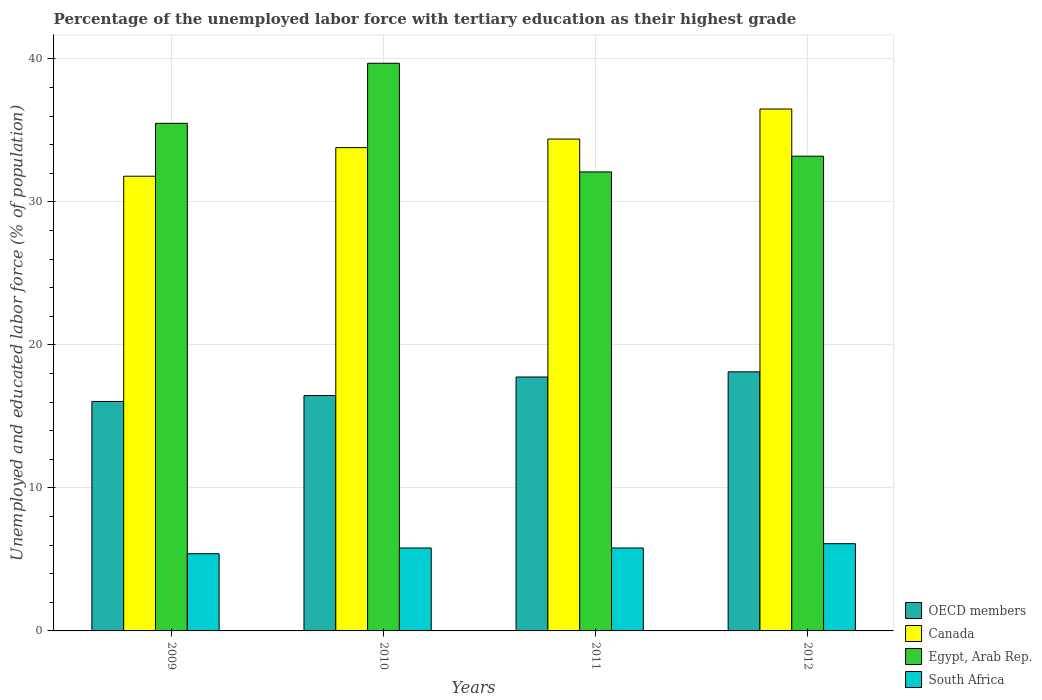How many different coloured bars are there?
Keep it short and to the point. 4. How many groups of bars are there?
Provide a succinct answer. 4. What is the percentage of the unemployed labor force with tertiary education in Canada in 2010?
Offer a very short reply. 33.8. Across all years, what is the maximum percentage of the unemployed labor force with tertiary education in OECD members?
Ensure brevity in your answer.  18.12. Across all years, what is the minimum percentage of the unemployed labor force with tertiary education in South Africa?
Your answer should be compact. 5.4. In which year was the percentage of the unemployed labor force with tertiary education in Egypt, Arab Rep. maximum?
Your answer should be compact. 2010. What is the total percentage of the unemployed labor force with tertiary education in Egypt, Arab Rep. in the graph?
Your answer should be very brief. 140.5. What is the difference between the percentage of the unemployed labor force with tertiary education in OECD members in 2009 and that in 2010?
Keep it short and to the point. -0.41. What is the difference between the percentage of the unemployed labor force with tertiary education in Egypt, Arab Rep. in 2011 and the percentage of the unemployed labor force with tertiary education in OECD members in 2010?
Offer a very short reply. 15.64. What is the average percentage of the unemployed labor force with tertiary education in South Africa per year?
Give a very brief answer. 5.78. In the year 2009, what is the difference between the percentage of the unemployed labor force with tertiary education in Canada and percentage of the unemployed labor force with tertiary education in Egypt, Arab Rep.?
Your answer should be compact. -3.7. In how many years, is the percentage of the unemployed labor force with tertiary education in South Africa greater than 2 %?
Ensure brevity in your answer.  4. What is the ratio of the percentage of the unemployed labor force with tertiary education in OECD members in 2010 to that in 2011?
Make the answer very short. 0.93. What is the difference between the highest and the second highest percentage of the unemployed labor force with tertiary education in Canada?
Give a very brief answer. 2.1. What is the difference between the highest and the lowest percentage of the unemployed labor force with tertiary education in South Africa?
Your response must be concise. 0.7. In how many years, is the percentage of the unemployed labor force with tertiary education in South Africa greater than the average percentage of the unemployed labor force with tertiary education in South Africa taken over all years?
Offer a very short reply. 3. Is the sum of the percentage of the unemployed labor force with tertiary education in OECD members in 2011 and 2012 greater than the maximum percentage of the unemployed labor force with tertiary education in Egypt, Arab Rep. across all years?
Your answer should be compact. No. Is it the case that in every year, the sum of the percentage of the unemployed labor force with tertiary education in Egypt, Arab Rep. and percentage of the unemployed labor force with tertiary education in South Africa is greater than the sum of percentage of the unemployed labor force with tertiary education in Canada and percentage of the unemployed labor force with tertiary education in OECD members?
Your response must be concise. No. What does the 2nd bar from the left in 2012 represents?
Your response must be concise. Canada. Are all the bars in the graph horizontal?
Ensure brevity in your answer.  No. Are the values on the major ticks of Y-axis written in scientific E-notation?
Offer a terse response. No. Does the graph contain any zero values?
Your answer should be compact. No. How are the legend labels stacked?
Keep it short and to the point. Vertical. What is the title of the graph?
Make the answer very short. Percentage of the unemployed labor force with tertiary education as their highest grade. What is the label or title of the X-axis?
Provide a short and direct response. Years. What is the label or title of the Y-axis?
Your response must be concise. Unemployed and educated labor force (% of population). What is the Unemployed and educated labor force (% of population) in OECD members in 2009?
Ensure brevity in your answer.  16.05. What is the Unemployed and educated labor force (% of population) in Canada in 2009?
Keep it short and to the point. 31.8. What is the Unemployed and educated labor force (% of population) in Egypt, Arab Rep. in 2009?
Your answer should be very brief. 35.5. What is the Unemployed and educated labor force (% of population) in South Africa in 2009?
Your answer should be compact. 5.4. What is the Unemployed and educated labor force (% of population) of OECD members in 2010?
Your answer should be compact. 16.46. What is the Unemployed and educated labor force (% of population) of Canada in 2010?
Offer a terse response. 33.8. What is the Unemployed and educated labor force (% of population) of Egypt, Arab Rep. in 2010?
Ensure brevity in your answer.  39.7. What is the Unemployed and educated labor force (% of population) in South Africa in 2010?
Your answer should be very brief. 5.8. What is the Unemployed and educated labor force (% of population) of OECD members in 2011?
Keep it short and to the point. 17.76. What is the Unemployed and educated labor force (% of population) in Canada in 2011?
Ensure brevity in your answer.  34.4. What is the Unemployed and educated labor force (% of population) in Egypt, Arab Rep. in 2011?
Ensure brevity in your answer.  32.1. What is the Unemployed and educated labor force (% of population) of South Africa in 2011?
Give a very brief answer. 5.8. What is the Unemployed and educated labor force (% of population) of OECD members in 2012?
Your answer should be compact. 18.12. What is the Unemployed and educated labor force (% of population) in Canada in 2012?
Your answer should be very brief. 36.5. What is the Unemployed and educated labor force (% of population) of Egypt, Arab Rep. in 2012?
Make the answer very short. 33.2. What is the Unemployed and educated labor force (% of population) in South Africa in 2012?
Your answer should be very brief. 6.1. Across all years, what is the maximum Unemployed and educated labor force (% of population) of OECD members?
Make the answer very short. 18.12. Across all years, what is the maximum Unemployed and educated labor force (% of population) in Canada?
Your answer should be very brief. 36.5. Across all years, what is the maximum Unemployed and educated labor force (% of population) in Egypt, Arab Rep.?
Provide a short and direct response. 39.7. Across all years, what is the maximum Unemployed and educated labor force (% of population) in South Africa?
Ensure brevity in your answer.  6.1. Across all years, what is the minimum Unemployed and educated labor force (% of population) of OECD members?
Your answer should be very brief. 16.05. Across all years, what is the minimum Unemployed and educated labor force (% of population) in Canada?
Give a very brief answer. 31.8. Across all years, what is the minimum Unemployed and educated labor force (% of population) in Egypt, Arab Rep.?
Your response must be concise. 32.1. Across all years, what is the minimum Unemployed and educated labor force (% of population) of South Africa?
Offer a very short reply. 5.4. What is the total Unemployed and educated labor force (% of population) in OECD members in the graph?
Keep it short and to the point. 68.39. What is the total Unemployed and educated labor force (% of population) of Canada in the graph?
Your response must be concise. 136.5. What is the total Unemployed and educated labor force (% of population) of Egypt, Arab Rep. in the graph?
Your answer should be very brief. 140.5. What is the total Unemployed and educated labor force (% of population) in South Africa in the graph?
Provide a short and direct response. 23.1. What is the difference between the Unemployed and educated labor force (% of population) of OECD members in 2009 and that in 2010?
Offer a very short reply. -0.41. What is the difference between the Unemployed and educated labor force (% of population) of Canada in 2009 and that in 2010?
Give a very brief answer. -2. What is the difference between the Unemployed and educated labor force (% of population) in OECD members in 2009 and that in 2011?
Give a very brief answer. -1.71. What is the difference between the Unemployed and educated labor force (% of population) in Canada in 2009 and that in 2011?
Your response must be concise. -2.6. What is the difference between the Unemployed and educated labor force (% of population) in South Africa in 2009 and that in 2011?
Provide a short and direct response. -0.4. What is the difference between the Unemployed and educated labor force (% of population) of OECD members in 2009 and that in 2012?
Make the answer very short. -2.07. What is the difference between the Unemployed and educated labor force (% of population) in Egypt, Arab Rep. in 2009 and that in 2012?
Offer a terse response. 2.3. What is the difference between the Unemployed and educated labor force (% of population) of OECD members in 2010 and that in 2011?
Make the answer very short. -1.3. What is the difference between the Unemployed and educated labor force (% of population) in Canada in 2010 and that in 2011?
Your answer should be compact. -0.6. What is the difference between the Unemployed and educated labor force (% of population) in South Africa in 2010 and that in 2011?
Your answer should be compact. 0. What is the difference between the Unemployed and educated labor force (% of population) of OECD members in 2010 and that in 2012?
Keep it short and to the point. -1.66. What is the difference between the Unemployed and educated labor force (% of population) of Egypt, Arab Rep. in 2010 and that in 2012?
Offer a terse response. 6.5. What is the difference between the Unemployed and educated labor force (% of population) of South Africa in 2010 and that in 2012?
Your response must be concise. -0.3. What is the difference between the Unemployed and educated labor force (% of population) in OECD members in 2011 and that in 2012?
Your answer should be very brief. -0.36. What is the difference between the Unemployed and educated labor force (% of population) of OECD members in 2009 and the Unemployed and educated labor force (% of population) of Canada in 2010?
Give a very brief answer. -17.75. What is the difference between the Unemployed and educated labor force (% of population) in OECD members in 2009 and the Unemployed and educated labor force (% of population) in Egypt, Arab Rep. in 2010?
Provide a short and direct response. -23.65. What is the difference between the Unemployed and educated labor force (% of population) in OECD members in 2009 and the Unemployed and educated labor force (% of population) in South Africa in 2010?
Keep it short and to the point. 10.25. What is the difference between the Unemployed and educated labor force (% of population) of Canada in 2009 and the Unemployed and educated labor force (% of population) of Egypt, Arab Rep. in 2010?
Provide a short and direct response. -7.9. What is the difference between the Unemployed and educated labor force (% of population) of Egypt, Arab Rep. in 2009 and the Unemployed and educated labor force (% of population) of South Africa in 2010?
Keep it short and to the point. 29.7. What is the difference between the Unemployed and educated labor force (% of population) of OECD members in 2009 and the Unemployed and educated labor force (% of population) of Canada in 2011?
Your response must be concise. -18.35. What is the difference between the Unemployed and educated labor force (% of population) of OECD members in 2009 and the Unemployed and educated labor force (% of population) of Egypt, Arab Rep. in 2011?
Your answer should be compact. -16.05. What is the difference between the Unemployed and educated labor force (% of population) in OECD members in 2009 and the Unemployed and educated labor force (% of population) in South Africa in 2011?
Give a very brief answer. 10.25. What is the difference between the Unemployed and educated labor force (% of population) of Egypt, Arab Rep. in 2009 and the Unemployed and educated labor force (% of population) of South Africa in 2011?
Give a very brief answer. 29.7. What is the difference between the Unemployed and educated labor force (% of population) of OECD members in 2009 and the Unemployed and educated labor force (% of population) of Canada in 2012?
Offer a very short reply. -20.45. What is the difference between the Unemployed and educated labor force (% of population) of OECD members in 2009 and the Unemployed and educated labor force (% of population) of Egypt, Arab Rep. in 2012?
Your answer should be very brief. -17.15. What is the difference between the Unemployed and educated labor force (% of population) in OECD members in 2009 and the Unemployed and educated labor force (% of population) in South Africa in 2012?
Make the answer very short. 9.95. What is the difference between the Unemployed and educated labor force (% of population) in Canada in 2009 and the Unemployed and educated labor force (% of population) in South Africa in 2012?
Offer a very short reply. 25.7. What is the difference between the Unemployed and educated labor force (% of population) in Egypt, Arab Rep. in 2009 and the Unemployed and educated labor force (% of population) in South Africa in 2012?
Provide a succinct answer. 29.4. What is the difference between the Unemployed and educated labor force (% of population) in OECD members in 2010 and the Unemployed and educated labor force (% of population) in Canada in 2011?
Offer a very short reply. -17.94. What is the difference between the Unemployed and educated labor force (% of population) of OECD members in 2010 and the Unemployed and educated labor force (% of population) of Egypt, Arab Rep. in 2011?
Provide a succinct answer. -15.64. What is the difference between the Unemployed and educated labor force (% of population) in OECD members in 2010 and the Unemployed and educated labor force (% of population) in South Africa in 2011?
Give a very brief answer. 10.66. What is the difference between the Unemployed and educated labor force (% of population) in Canada in 2010 and the Unemployed and educated labor force (% of population) in Egypt, Arab Rep. in 2011?
Your answer should be compact. 1.7. What is the difference between the Unemployed and educated labor force (% of population) of Egypt, Arab Rep. in 2010 and the Unemployed and educated labor force (% of population) of South Africa in 2011?
Offer a terse response. 33.9. What is the difference between the Unemployed and educated labor force (% of population) in OECD members in 2010 and the Unemployed and educated labor force (% of population) in Canada in 2012?
Ensure brevity in your answer.  -20.04. What is the difference between the Unemployed and educated labor force (% of population) in OECD members in 2010 and the Unemployed and educated labor force (% of population) in Egypt, Arab Rep. in 2012?
Give a very brief answer. -16.74. What is the difference between the Unemployed and educated labor force (% of population) in OECD members in 2010 and the Unemployed and educated labor force (% of population) in South Africa in 2012?
Ensure brevity in your answer.  10.36. What is the difference between the Unemployed and educated labor force (% of population) of Canada in 2010 and the Unemployed and educated labor force (% of population) of South Africa in 2012?
Ensure brevity in your answer.  27.7. What is the difference between the Unemployed and educated labor force (% of population) in Egypt, Arab Rep. in 2010 and the Unemployed and educated labor force (% of population) in South Africa in 2012?
Provide a short and direct response. 33.6. What is the difference between the Unemployed and educated labor force (% of population) in OECD members in 2011 and the Unemployed and educated labor force (% of population) in Canada in 2012?
Your answer should be compact. -18.74. What is the difference between the Unemployed and educated labor force (% of population) in OECD members in 2011 and the Unemployed and educated labor force (% of population) in Egypt, Arab Rep. in 2012?
Provide a short and direct response. -15.44. What is the difference between the Unemployed and educated labor force (% of population) of OECD members in 2011 and the Unemployed and educated labor force (% of population) of South Africa in 2012?
Your answer should be compact. 11.66. What is the difference between the Unemployed and educated labor force (% of population) in Canada in 2011 and the Unemployed and educated labor force (% of population) in Egypt, Arab Rep. in 2012?
Offer a very short reply. 1.2. What is the difference between the Unemployed and educated labor force (% of population) of Canada in 2011 and the Unemployed and educated labor force (% of population) of South Africa in 2012?
Give a very brief answer. 28.3. What is the average Unemployed and educated labor force (% of population) in OECD members per year?
Provide a short and direct response. 17.1. What is the average Unemployed and educated labor force (% of population) in Canada per year?
Keep it short and to the point. 34.12. What is the average Unemployed and educated labor force (% of population) in Egypt, Arab Rep. per year?
Offer a very short reply. 35.12. What is the average Unemployed and educated labor force (% of population) in South Africa per year?
Provide a succinct answer. 5.78. In the year 2009, what is the difference between the Unemployed and educated labor force (% of population) of OECD members and Unemployed and educated labor force (% of population) of Canada?
Your response must be concise. -15.75. In the year 2009, what is the difference between the Unemployed and educated labor force (% of population) in OECD members and Unemployed and educated labor force (% of population) in Egypt, Arab Rep.?
Give a very brief answer. -19.45. In the year 2009, what is the difference between the Unemployed and educated labor force (% of population) of OECD members and Unemployed and educated labor force (% of population) of South Africa?
Keep it short and to the point. 10.65. In the year 2009, what is the difference between the Unemployed and educated labor force (% of population) in Canada and Unemployed and educated labor force (% of population) in Egypt, Arab Rep.?
Offer a terse response. -3.7. In the year 2009, what is the difference between the Unemployed and educated labor force (% of population) in Canada and Unemployed and educated labor force (% of population) in South Africa?
Offer a very short reply. 26.4. In the year 2009, what is the difference between the Unemployed and educated labor force (% of population) in Egypt, Arab Rep. and Unemployed and educated labor force (% of population) in South Africa?
Keep it short and to the point. 30.1. In the year 2010, what is the difference between the Unemployed and educated labor force (% of population) of OECD members and Unemployed and educated labor force (% of population) of Canada?
Offer a terse response. -17.34. In the year 2010, what is the difference between the Unemployed and educated labor force (% of population) of OECD members and Unemployed and educated labor force (% of population) of Egypt, Arab Rep.?
Your answer should be very brief. -23.24. In the year 2010, what is the difference between the Unemployed and educated labor force (% of population) in OECD members and Unemployed and educated labor force (% of population) in South Africa?
Make the answer very short. 10.66. In the year 2010, what is the difference between the Unemployed and educated labor force (% of population) in Canada and Unemployed and educated labor force (% of population) in South Africa?
Ensure brevity in your answer.  28. In the year 2010, what is the difference between the Unemployed and educated labor force (% of population) in Egypt, Arab Rep. and Unemployed and educated labor force (% of population) in South Africa?
Your answer should be very brief. 33.9. In the year 2011, what is the difference between the Unemployed and educated labor force (% of population) in OECD members and Unemployed and educated labor force (% of population) in Canada?
Make the answer very short. -16.64. In the year 2011, what is the difference between the Unemployed and educated labor force (% of population) in OECD members and Unemployed and educated labor force (% of population) in Egypt, Arab Rep.?
Your answer should be very brief. -14.34. In the year 2011, what is the difference between the Unemployed and educated labor force (% of population) of OECD members and Unemployed and educated labor force (% of population) of South Africa?
Your answer should be compact. 11.96. In the year 2011, what is the difference between the Unemployed and educated labor force (% of population) of Canada and Unemployed and educated labor force (% of population) of Egypt, Arab Rep.?
Ensure brevity in your answer.  2.3. In the year 2011, what is the difference between the Unemployed and educated labor force (% of population) in Canada and Unemployed and educated labor force (% of population) in South Africa?
Ensure brevity in your answer.  28.6. In the year 2011, what is the difference between the Unemployed and educated labor force (% of population) of Egypt, Arab Rep. and Unemployed and educated labor force (% of population) of South Africa?
Your answer should be compact. 26.3. In the year 2012, what is the difference between the Unemployed and educated labor force (% of population) of OECD members and Unemployed and educated labor force (% of population) of Canada?
Your answer should be very brief. -18.38. In the year 2012, what is the difference between the Unemployed and educated labor force (% of population) in OECD members and Unemployed and educated labor force (% of population) in Egypt, Arab Rep.?
Your answer should be compact. -15.08. In the year 2012, what is the difference between the Unemployed and educated labor force (% of population) of OECD members and Unemployed and educated labor force (% of population) of South Africa?
Your answer should be compact. 12.02. In the year 2012, what is the difference between the Unemployed and educated labor force (% of population) in Canada and Unemployed and educated labor force (% of population) in Egypt, Arab Rep.?
Give a very brief answer. 3.3. In the year 2012, what is the difference between the Unemployed and educated labor force (% of population) in Canada and Unemployed and educated labor force (% of population) in South Africa?
Ensure brevity in your answer.  30.4. In the year 2012, what is the difference between the Unemployed and educated labor force (% of population) in Egypt, Arab Rep. and Unemployed and educated labor force (% of population) in South Africa?
Offer a terse response. 27.1. What is the ratio of the Unemployed and educated labor force (% of population) in OECD members in 2009 to that in 2010?
Ensure brevity in your answer.  0.97. What is the ratio of the Unemployed and educated labor force (% of population) in Canada in 2009 to that in 2010?
Give a very brief answer. 0.94. What is the ratio of the Unemployed and educated labor force (% of population) in Egypt, Arab Rep. in 2009 to that in 2010?
Keep it short and to the point. 0.89. What is the ratio of the Unemployed and educated labor force (% of population) in OECD members in 2009 to that in 2011?
Provide a short and direct response. 0.9. What is the ratio of the Unemployed and educated labor force (% of population) of Canada in 2009 to that in 2011?
Give a very brief answer. 0.92. What is the ratio of the Unemployed and educated labor force (% of population) of Egypt, Arab Rep. in 2009 to that in 2011?
Offer a terse response. 1.11. What is the ratio of the Unemployed and educated labor force (% of population) in South Africa in 2009 to that in 2011?
Provide a succinct answer. 0.93. What is the ratio of the Unemployed and educated labor force (% of population) in OECD members in 2009 to that in 2012?
Ensure brevity in your answer.  0.89. What is the ratio of the Unemployed and educated labor force (% of population) in Canada in 2009 to that in 2012?
Ensure brevity in your answer.  0.87. What is the ratio of the Unemployed and educated labor force (% of population) in Egypt, Arab Rep. in 2009 to that in 2012?
Keep it short and to the point. 1.07. What is the ratio of the Unemployed and educated labor force (% of population) in South Africa in 2009 to that in 2012?
Provide a succinct answer. 0.89. What is the ratio of the Unemployed and educated labor force (% of population) of OECD members in 2010 to that in 2011?
Ensure brevity in your answer.  0.93. What is the ratio of the Unemployed and educated labor force (% of population) of Canada in 2010 to that in 2011?
Offer a very short reply. 0.98. What is the ratio of the Unemployed and educated labor force (% of population) of Egypt, Arab Rep. in 2010 to that in 2011?
Your answer should be very brief. 1.24. What is the ratio of the Unemployed and educated labor force (% of population) of South Africa in 2010 to that in 2011?
Your answer should be compact. 1. What is the ratio of the Unemployed and educated labor force (% of population) in OECD members in 2010 to that in 2012?
Provide a succinct answer. 0.91. What is the ratio of the Unemployed and educated labor force (% of population) in Canada in 2010 to that in 2012?
Offer a very short reply. 0.93. What is the ratio of the Unemployed and educated labor force (% of population) of Egypt, Arab Rep. in 2010 to that in 2012?
Provide a short and direct response. 1.2. What is the ratio of the Unemployed and educated labor force (% of population) of South Africa in 2010 to that in 2012?
Provide a short and direct response. 0.95. What is the ratio of the Unemployed and educated labor force (% of population) of OECD members in 2011 to that in 2012?
Make the answer very short. 0.98. What is the ratio of the Unemployed and educated labor force (% of population) in Canada in 2011 to that in 2012?
Offer a very short reply. 0.94. What is the ratio of the Unemployed and educated labor force (% of population) in Egypt, Arab Rep. in 2011 to that in 2012?
Keep it short and to the point. 0.97. What is the ratio of the Unemployed and educated labor force (% of population) in South Africa in 2011 to that in 2012?
Your answer should be very brief. 0.95. What is the difference between the highest and the second highest Unemployed and educated labor force (% of population) of OECD members?
Ensure brevity in your answer.  0.36. What is the difference between the highest and the second highest Unemployed and educated labor force (% of population) in Egypt, Arab Rep.?
Your answer should be compact. 4.2. What is the difference between the highest and the second highest Unemployed and educated labor force (% of population) of South Africa?
Ensure brevity in your answer.  0.3. What is the difference between the highest and the lowest Unemployed and educated labor force (% of population) in OECD members?
Give a very brief answer. 2.07. What is the difference between the highest and the lowest Unemployed and educated labor force (% of population) of Canada?
Provide a succinct answer. 4.7. What is the difference between the highest and the lowest Unemployed and educated labor force (% of population) in Egypt, Arab Rep.?
Your response must be concise. 7.6. What is the difference between the highest and the lowest Unemployed and educated labor force (% of population) in South Africa?
Give a very brief answer. 0.7. 